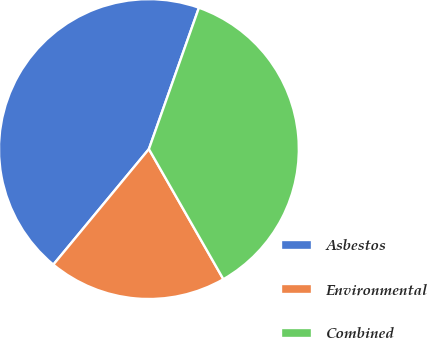<chart> <loc_0><loc_0><loc_500><loc_500><pie_chart><fcel>Asbestos<fcel>Environmental<fcel>Combined<nl><fcel>44.41%<fcel>19.27%<fcel>36.31%<nl></chart> 